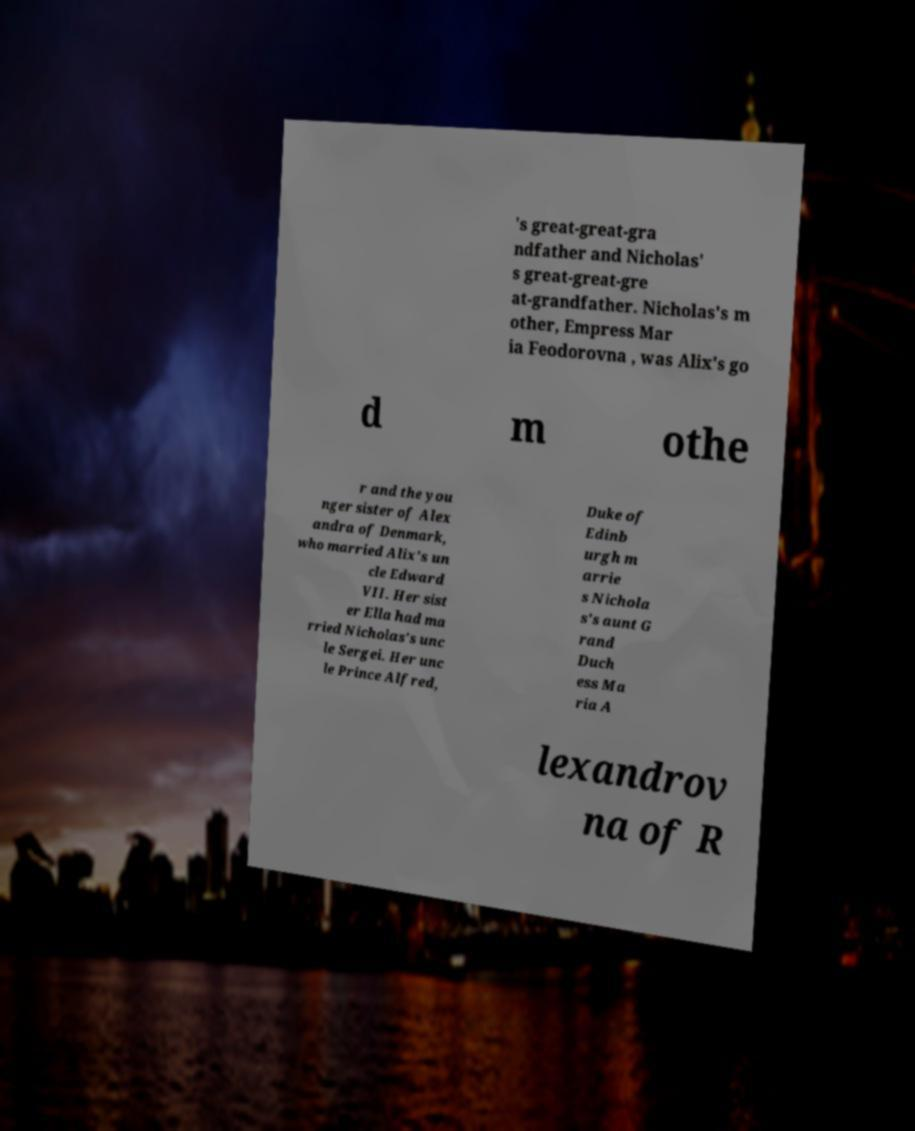I need the written content from this picture converted into text. Can you do that? 's great-great-gra ndfather and Nicholas' s great-great-gre at-grandfather. Nicholas's m other, Empress Mar ia Feodorovna , was Alix's go d m othe r and the you nger sister of Alex andra of Denmark, who married Alix's un cle Edward VII. Her sist er Ella had ma rried Nicholas's unc le Sergei. Her unc le Prince Alfred, Duke of Edinb urgh m arrie s Nichola s's aunt G rand Duch ess Ma ria A lexandrov na of R 